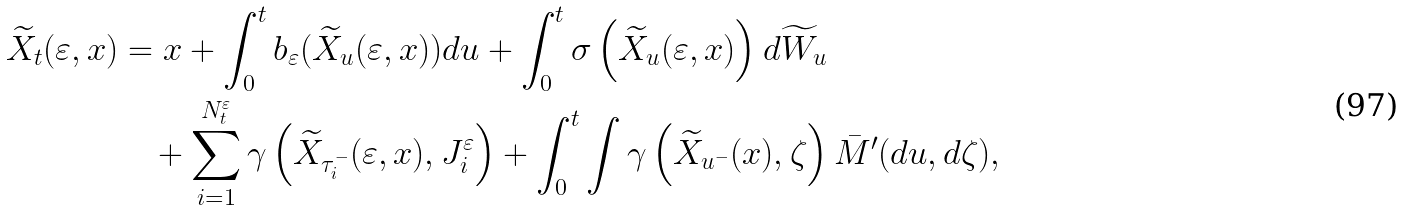<formula> <loc_0><loc_0><loc_500><loc_500>\widetilde { X } _ { t } ( \varepsilon , x ) & = x + \int _ { 0 } ^ { t } b _ { \varepsilon } ( \widetilde { X } _ { u } ( \varepsilon , x ) ) d u + \int _ { 0 } ^ { t } \sigma \left ( \widetilde { X } _ { u } ( \varepsilon , x ) \right ) d \widetilde { W } _ { u } \\ & \quad + \sum _ { i = 1 } ^ { N _ { t } ^ { \varepsilon } } \gamma \left ( \widetilde { X } _ { \tau _ { i } ^ { - } } ( \varepsilon , x ) , J _ { i } ^ { \varepsilon } \right ) + \int _ { 0 } ^ { t } \int \gamma \left ( \widetilde { X } _ { u ^ { - } } ( x ) , \zeta \right ) \bar { M } ^ { \prime } ( d u , d \zeta ) ,</formula> 